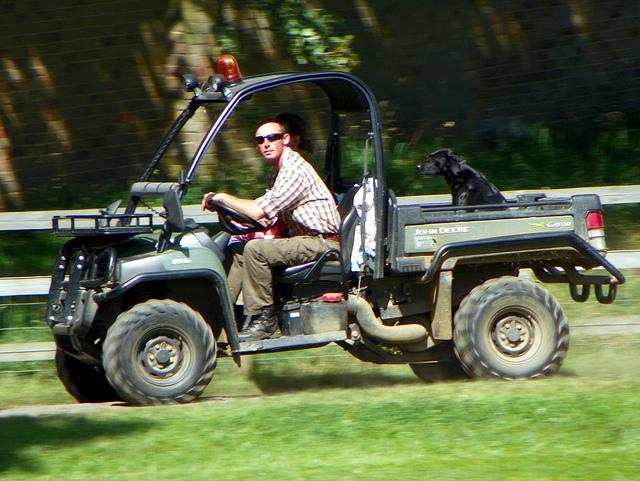Why is the dog in the back?

Choices:
A) broken truck
B) was bad
C) no room
D) snuck on no room 